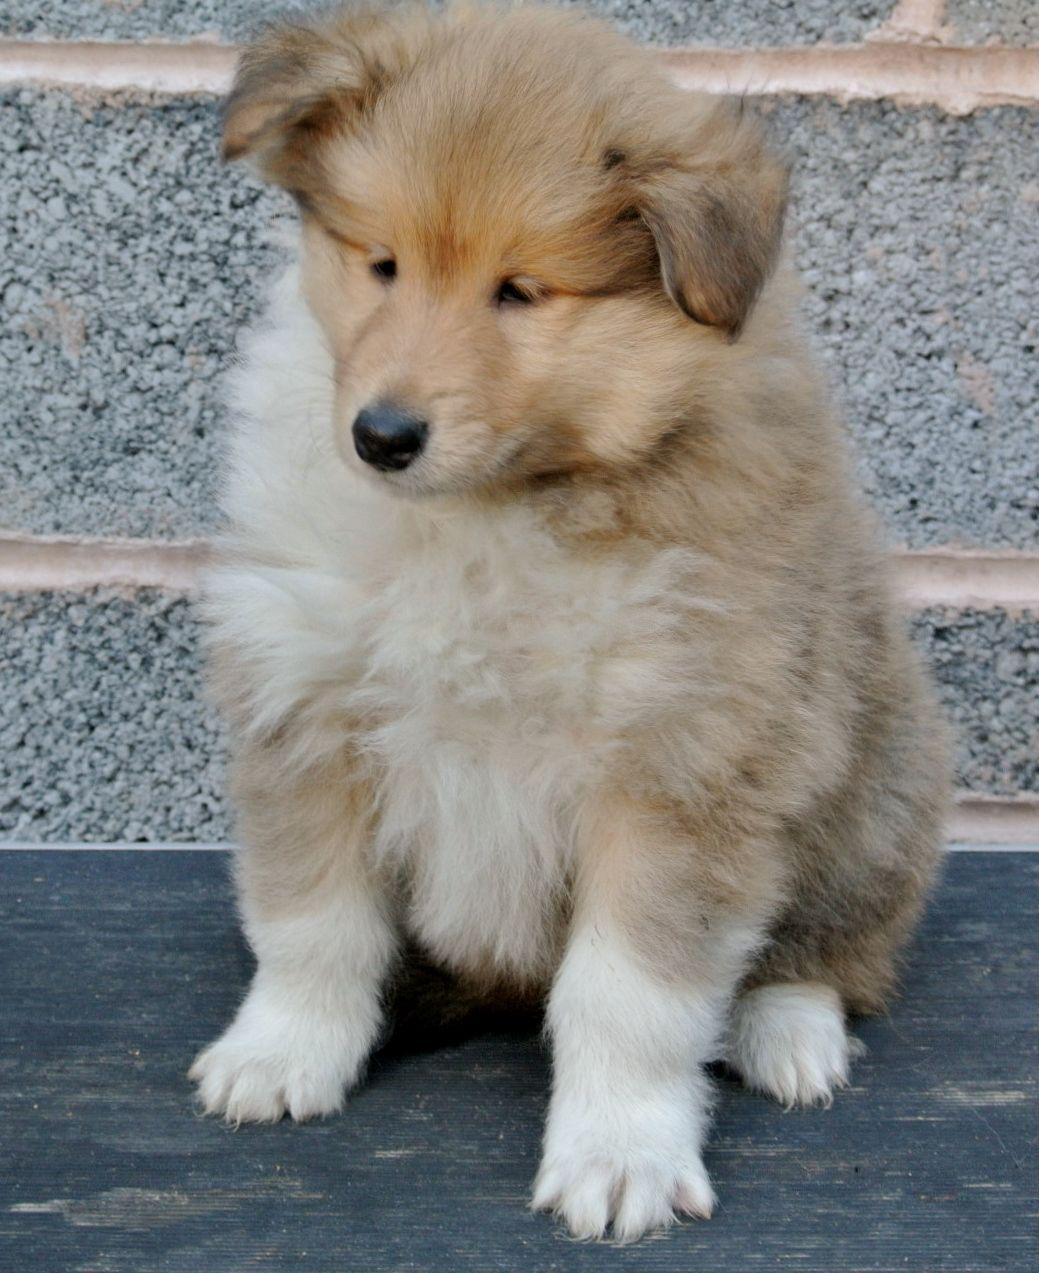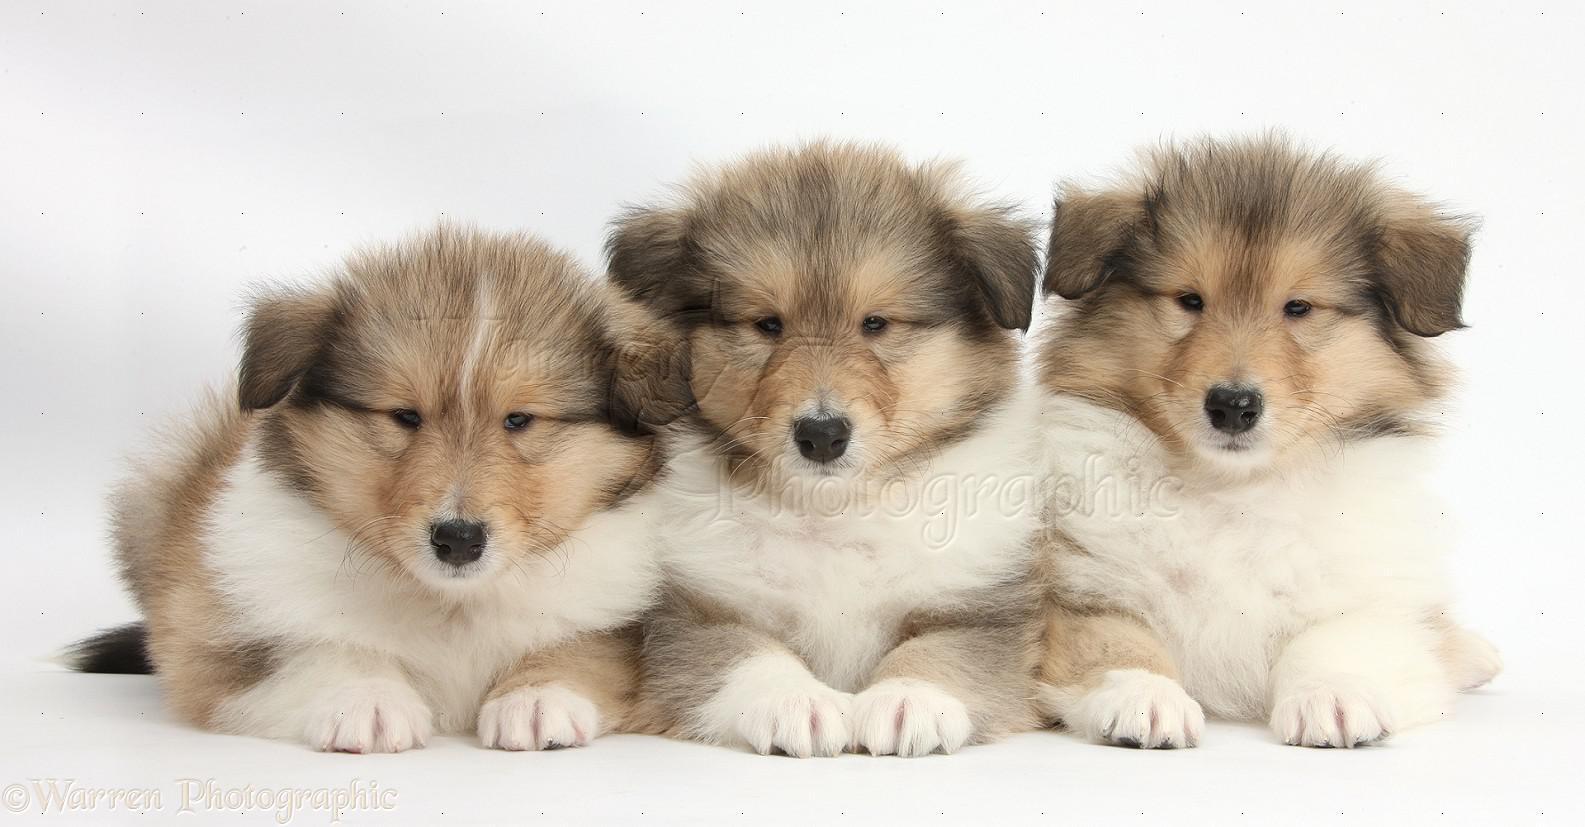The first image is the image on the left, the second image is the image on the right. Considering the images on both sides, is "There are at most 4 collies in the pair of images." valid? Answer yes or no. Yes. The first image is the image on the left, the second image is the image on the right. For the images shown, is this caption "The right image contains exactly three dogs." true? Answer yes or no. Yes. 